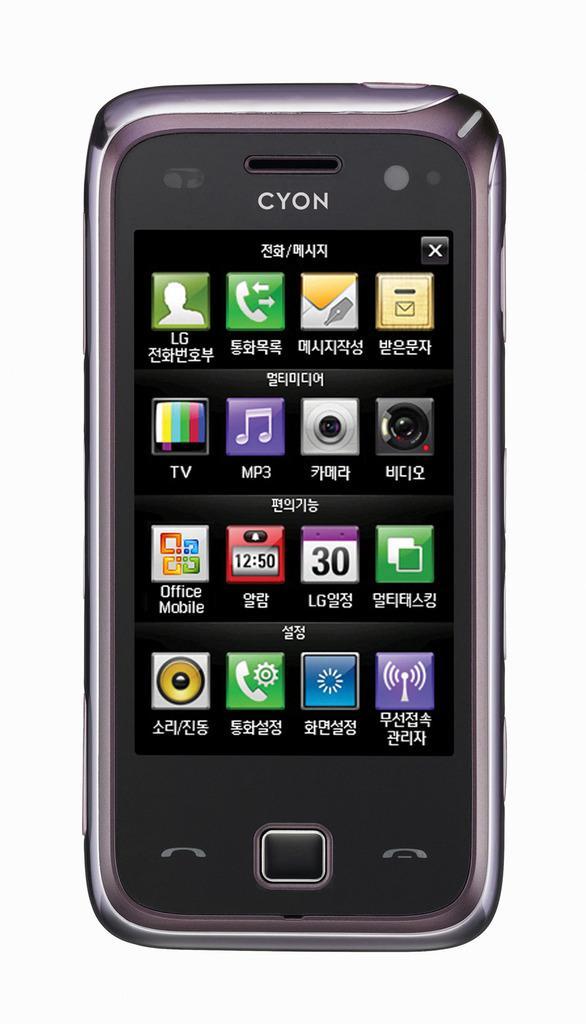Describe this image in one or two sentences. In this picture there is a cell phone in the center of the image. 